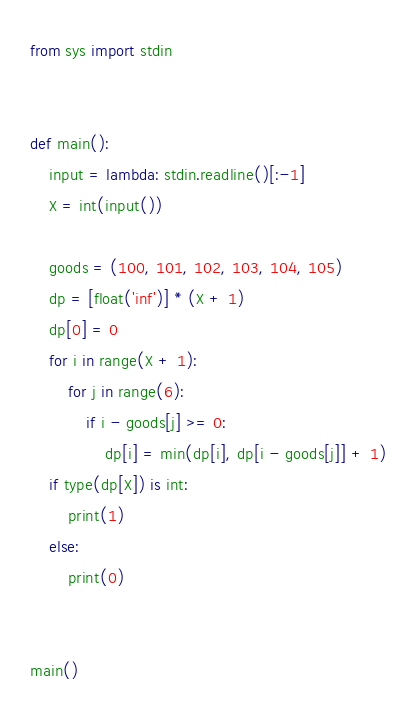Convert code to text. <code><loc_0><loc_0><loc_500><loc_500><_Python_>from sys import stdin


def main():
    input = lambda: stdin.readline()[:-1]
    X = int(input())

    goods = (100, 101, 102, 103, 104, 105)
    dp = [float('inf')] * (X + 1)
    dp[0] = 0
    for i in range(X + 1):
        for j in range(6):
            if i - goods[j] >= 0:
                dp[i] = min(dp[i], dp[i - goods[j]] + 1)
    if type(dp[X]) is int:
        print(1)
    else:
        print(0)


main()
</code> 